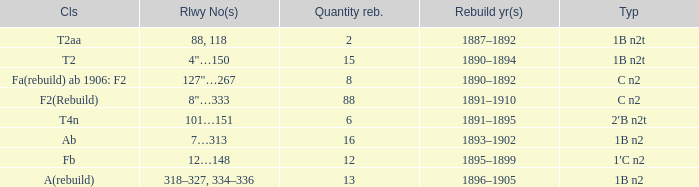What was the Rebuildjahr(e) for the T2AA class? 1887–1892. 